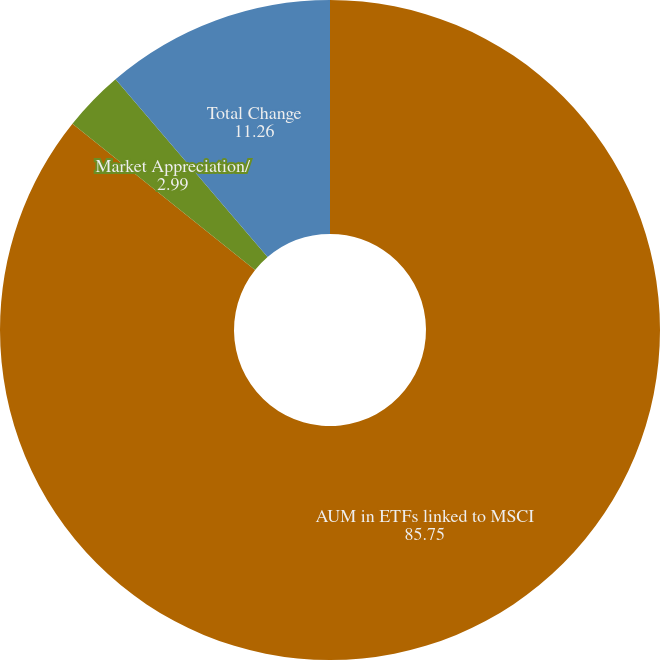Convert chart to OTSL. <chart><loc_0><loc_0><loc_500><loc_500><pie_chart><fcel>AUM in ETFs linked to MSCI<fcel>Market Appreciation/<fcel>Total Change<nl><fcel>85.75%<fcel>2.99%<fcel>11.26%<nl></chart> 